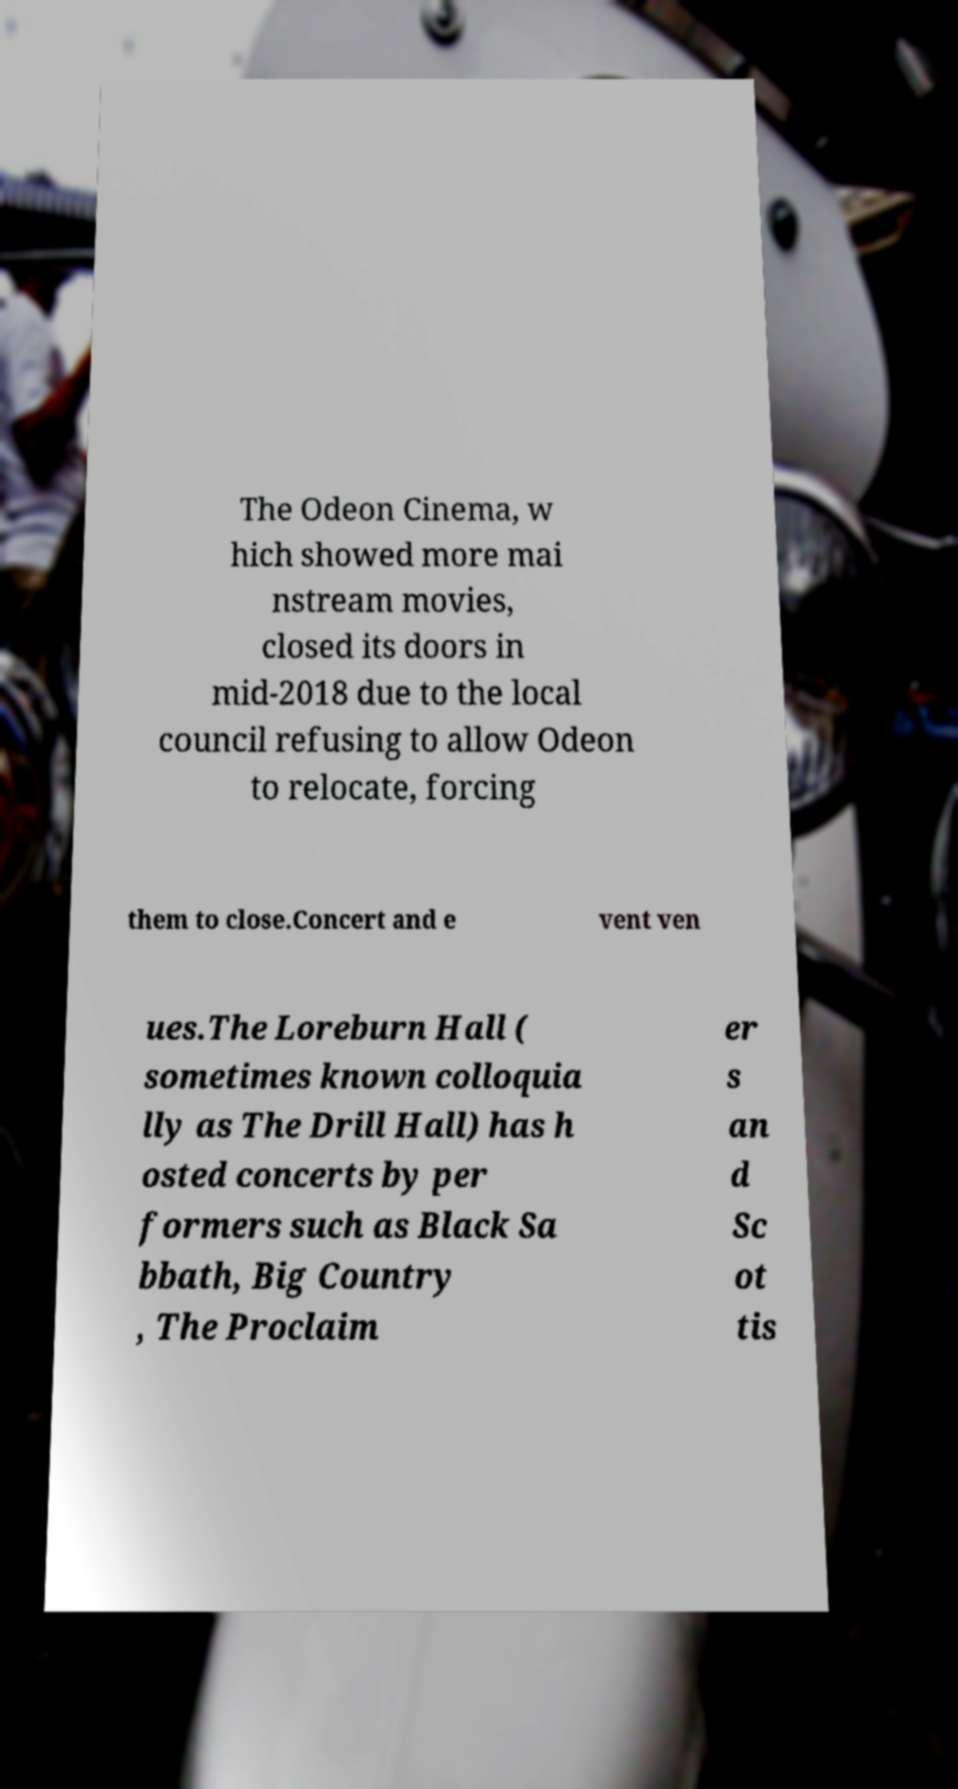Can you read and provide the text displayed in the image?This photo seems to have some interesting text. Can you extract and type it out for me? The Odeon Cinema, w hich showed more mai nstream movies, closed its doors in mid-2018 due to the local council refusing to allow Odeon to relocate, forcing them to close.Concert and e vent ven ues.The Loreburn Hall ( sometimes known colloquia lly as The Drill Hall) has h osted concerts by per formers such as Black Sa bbath, Big Country , The Proclaim er s an d Sc ot tis 